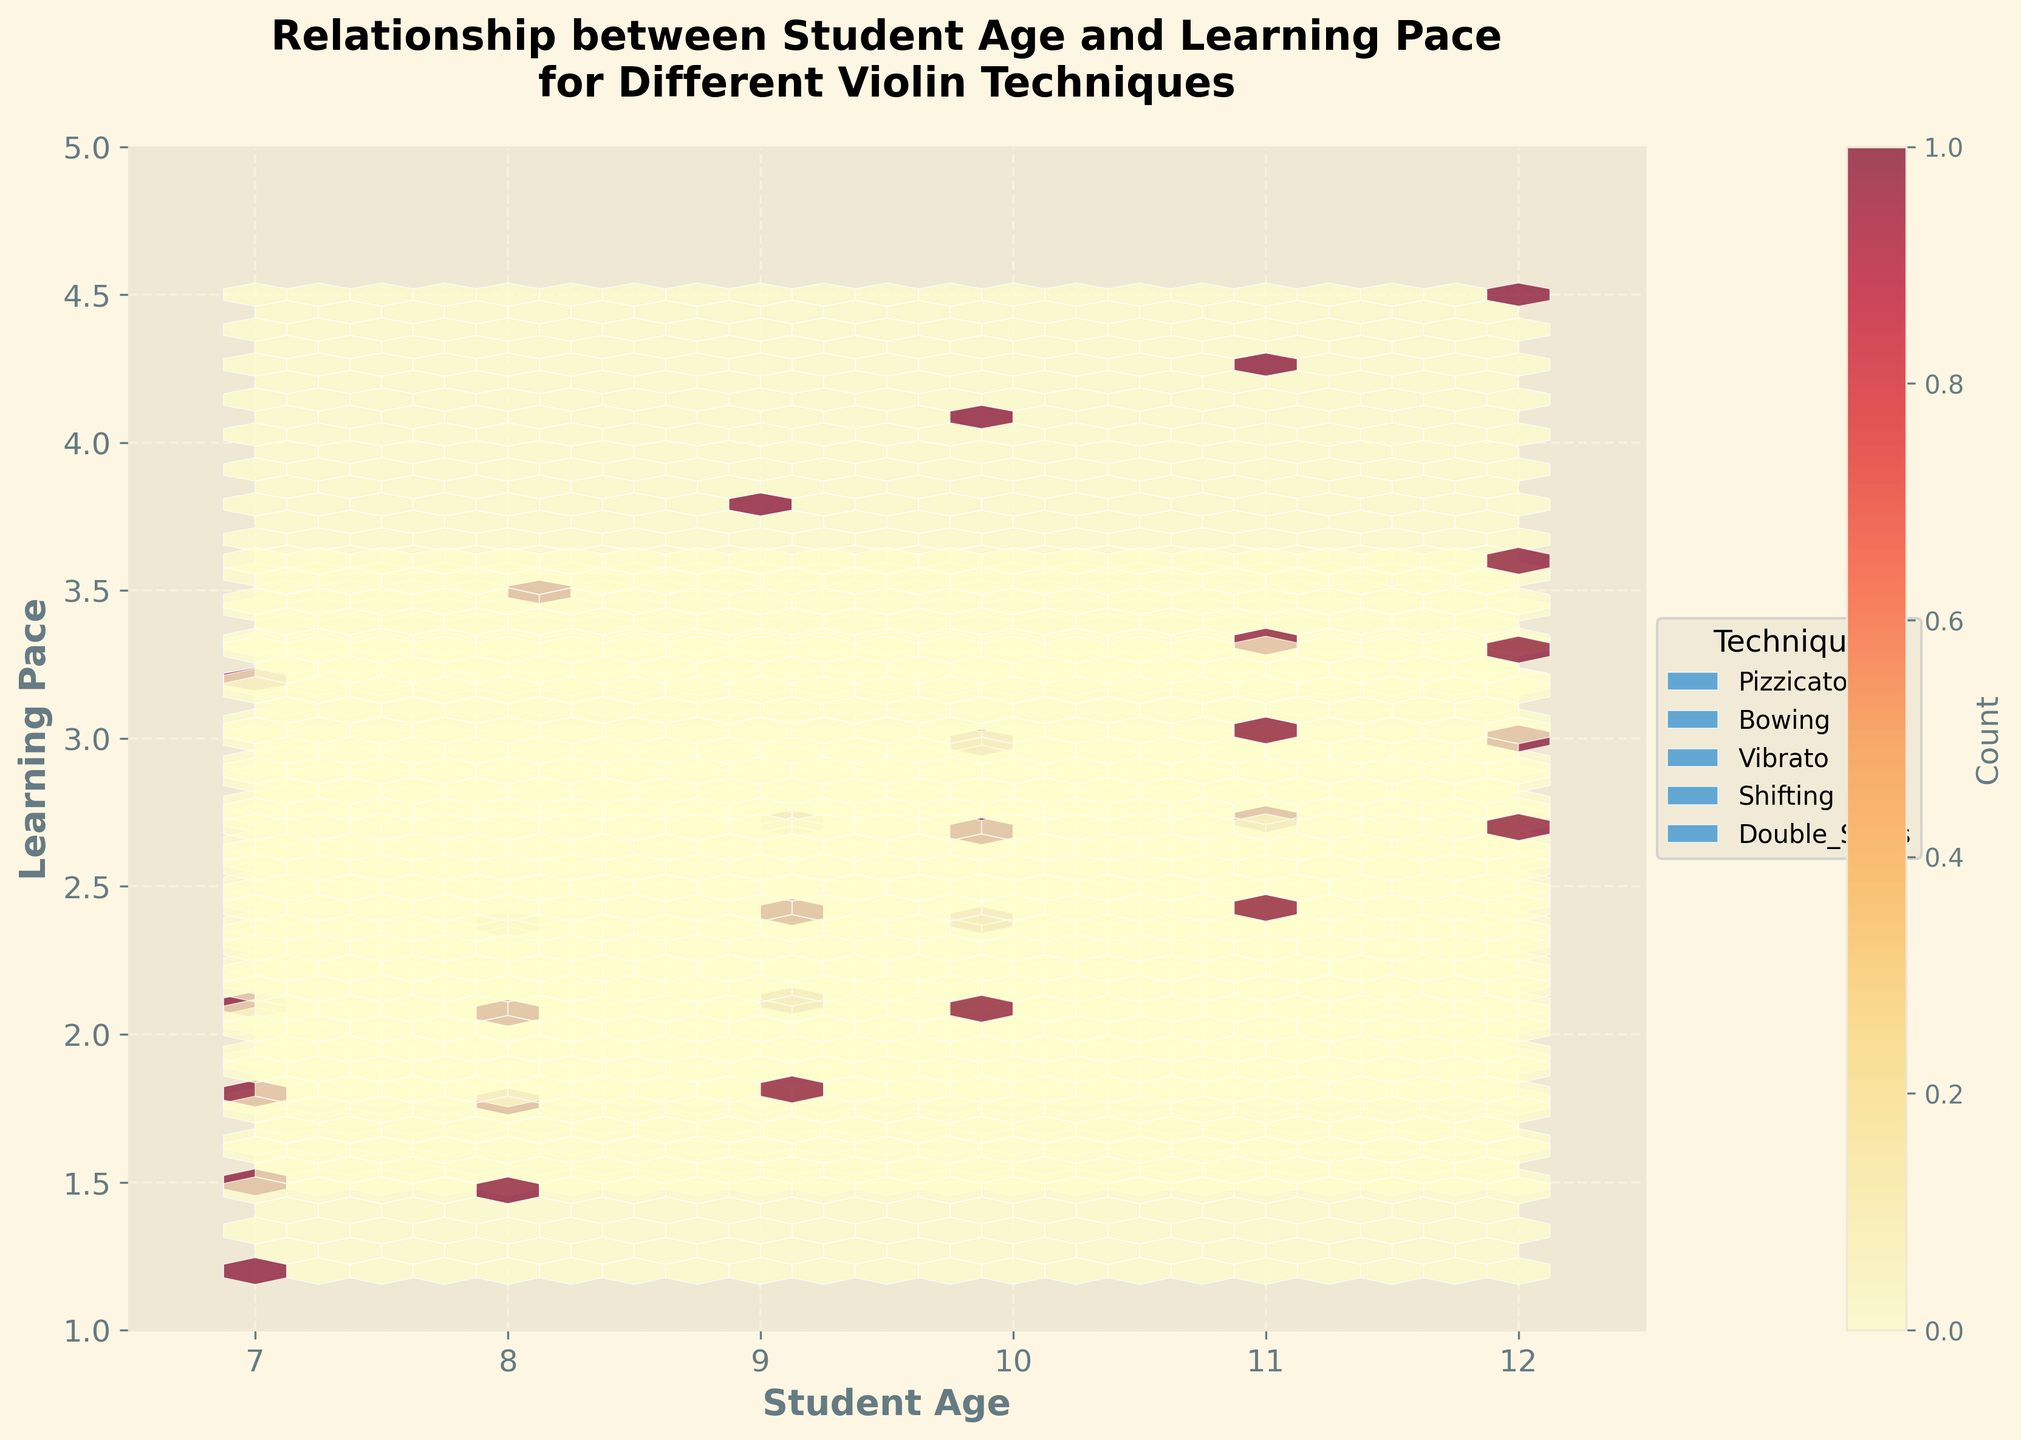What's the title of the plot? The title is displayed prominently at the top of the plot and reads "Relationship between Student Age and Learning Pace for Different Violin Techniques".
Answer: Relationship between Student Age and Learning Pace for Different Violin Techniques What do the x-axis and y-axis represent? The x-axis label, "Student Age", represents the age of the students, while the y-axis label, "Learning Pace", represents the learning pace for different violin techniques. These labels are clearly marked on the respective axes.
Answer: The x-axis represents Student Age and the y-axis represents Learning Pace What is the hexbin plot showing about the distribution of ages for the 'Pizzicato' technique? By observing the hexagons with the same shading pattern corresponding to the 'Pizzicato' technique, we can see that they form a vertical distribution clustered around ages 7 to 12, with the learning pace gradually increasing as age increases.
Answer: The ages range from 7 to 12 for 'Pizzicato' Which violin technique shows the lowest learning pace for a 7-year-old student? Looking at the x-axis at 7 years old, find the hexagon with the lowest y-coordinate value. The technique marked 'Double_Stops' has the lowest learning pace value at around 1.2 for a 7-year-old.
Answer: Double Stops Does the learning pace for 'Vibrato' exceed 3.0 for any age group? By visually tracking the 'Vibrato' hexagons on the plot, specifically the y-axis values, we see that no hexagon surpasses the y-value of 3.0, indicating that the learning pace for 'Vibrato' does not exceed 3.0 for any age group represented.
Answer: No Which violin technique shows the steepest increase in learning pace with age? Comparing the slopes of the learning pace increases for different techniques between ages 7 and 12, 'Pizzicato' shows a pronounced upward trend, indicating the steepest increase in learning pace with age.
Answer: Pizzicato Which age group demonstrates the widest range of learning paces across different techniques? By observing the range of learning paces (difference between the highest and lowest y-values) at each age, the 12-year-old group shows the widest range, spanning from approximately 2.7 to 4.5.
Answer: 12-year-old group How does the learning pace for 'Shifting' change as students age from 7 to 12? By tracing the 'Shifting' hexagons from age 7 up to age 12, the y-values gradually increase from around 1.8 to 3.3, indicating a steady rise in learning pace with age.
Answer: It gradually increases Which technique has the most consistently increasing learning pace as students age from 7 to 12? By looking at each technique's hexagons and observing the consistency and slope over the age range from 7 to 12, 'Pizzicato' exhibits the most consistent increase in learning pace as it shows a steady and linear upward trend.
Answer: Pizzicato 